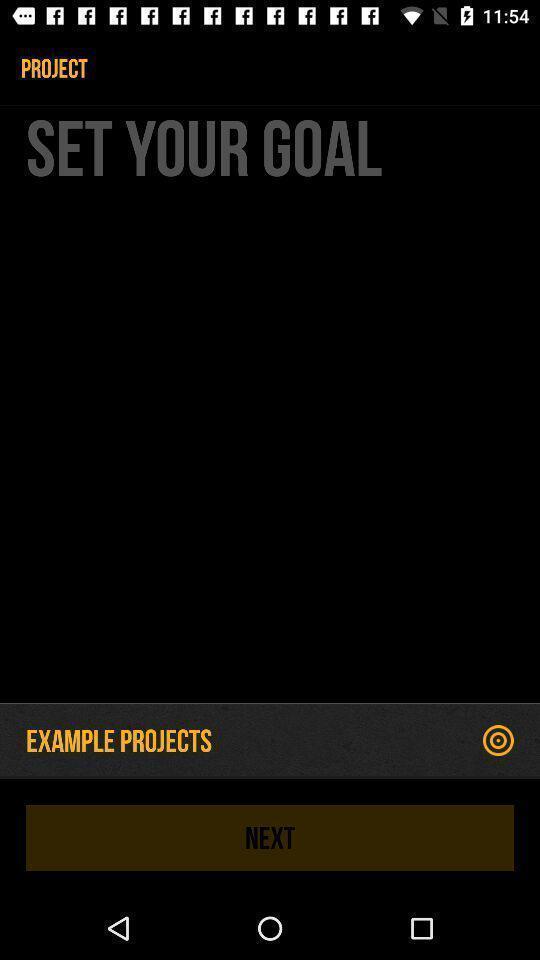Give me a summary of this screen capture. Project addition page with example projects. 